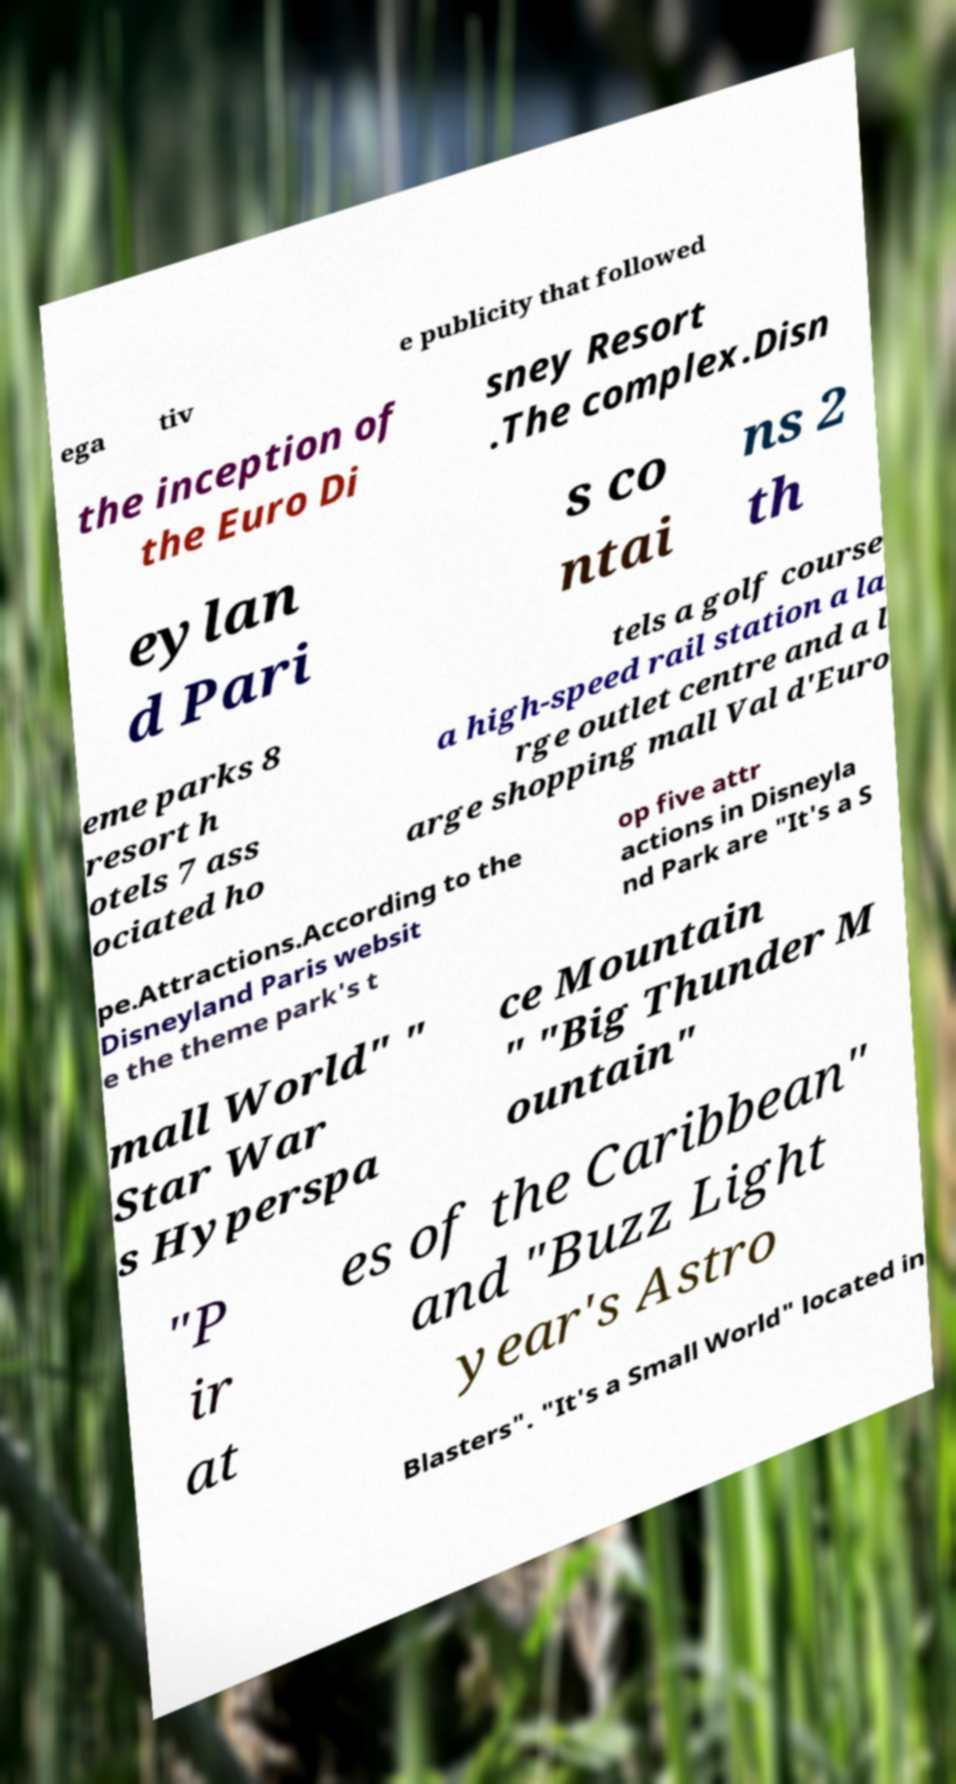For documentation purposes, I need the text within this image transcribed. Could you provide that? ega tiv e publicity that followed the inception of the Euro Di sney Resort .The complex.Disn eylan d Pari s co ntai ns 2 th eme parks 8 resort h otels 7 ass ociated ho tels a golf course a high-speed rail station a la rge outlet centre and a l arge shopping mall Val d'Euro pe.Attractions.According to the Disneyland Paris websit e the theme park's t op five attr actions in Disneyla nd Park are "It's a S mall World" " Star War s Hyperspa ce Mountain " "Big Thunder M ountain" "P ir at es of the Caribbean" and "Buzz Light year's Astro Blasters". "It's a Small World" located in 